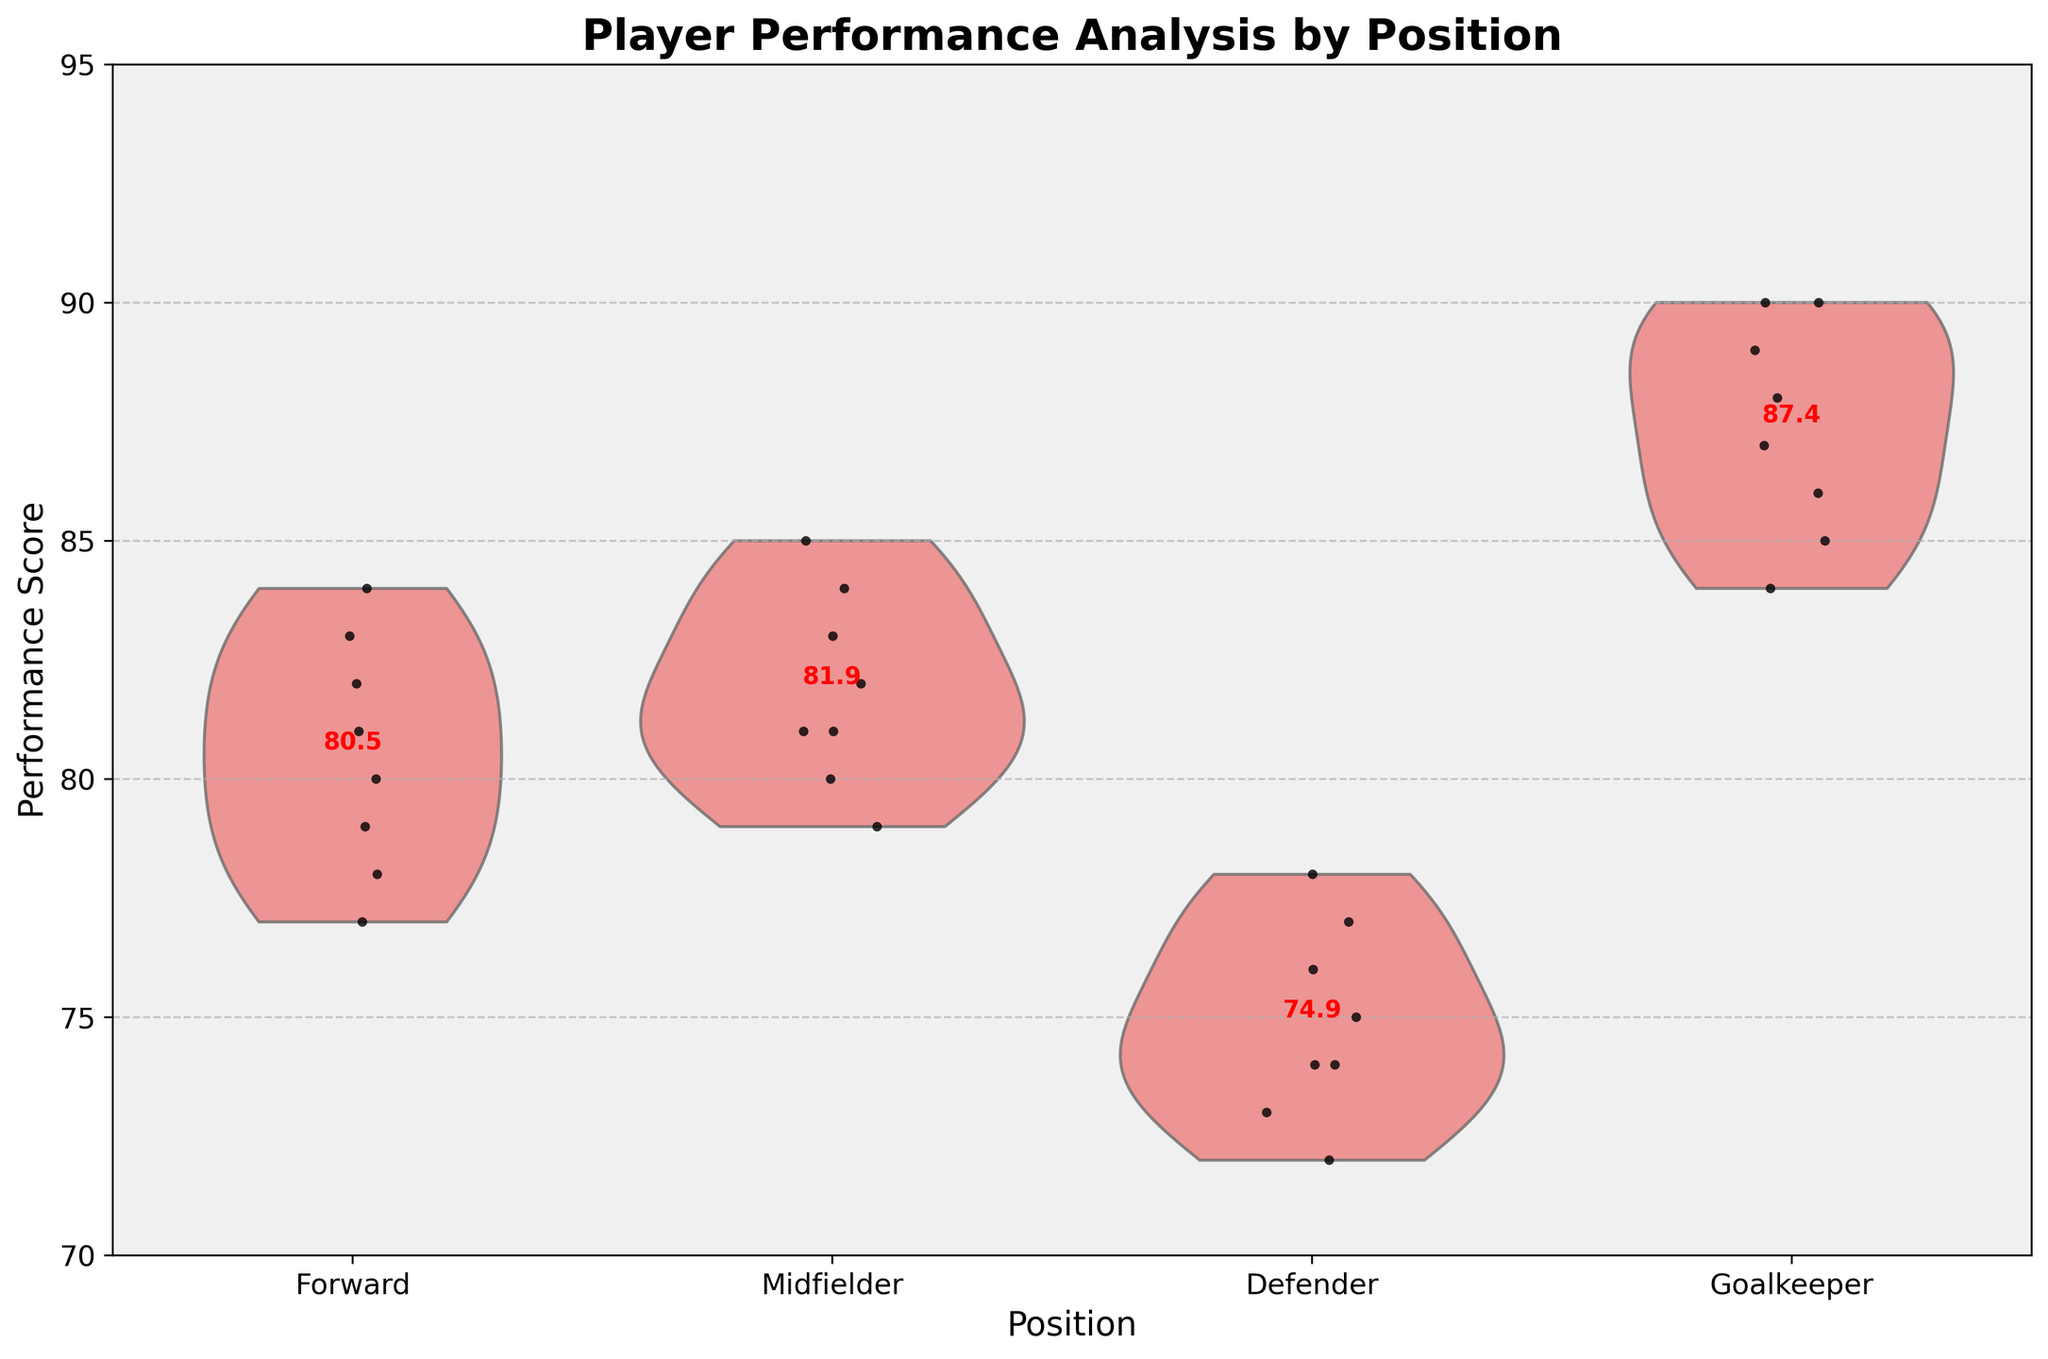What is the title of the chart? The title of the chart is found at the top and it summarizes the main information the chart intends to show. Here, it states "Player Performance Analysis by Position".
Answer: Player Performance Analysis by Position What positions are represented in the chart? The positions can be identified along the x-axis labels, which include Forward, Midfielder, Defender, and Goalkeeper.
Answer: Forward, Midfielder, Defender, Goalkeeper What is the range of performance scores shown in the y-axis? The y-axis provides the scale for the performance scores, ranging from the minimum value at the bottom to the maximum value at the top. In this plot, it ranges from 70 to 95.
Answer: 70 to 95 Which position has the highest mean performance score and what is its value? The mean performance scores are noted with red text at each position. The position with the highest mean value being annotated is the Goalkeeper with a mean score of 87.4.
Answer: Goalkeeper, 87.4 How does the mean performance score of Defenders compare to Forwards? To compare, we look at the mean scores annotated in red for both positions. Forwards have a mean score of 80.0, while Defenders have a mean score of 74.4.
Answer: Forwards: 80.0, Defenders: 74.4 Which position has the largest variability in performance scores? Variability can be observed by the width and spread of the violin plot. The position with the widest spread from top to bottom in its violin plot, indicating larger variability, is the Goalkeeper.
Answer: Goalkeeper Based on the jittered points, which position has the highest individual performance score and what is it? Jittered points, shown as black dots, represent individual scores. The highest point is near the top of the Goalkeeper's violin plot, at around 90.
Answer: Goalkeeper, 90 How does the spread of performance scores for Midfielders compare to Forwards? By examining the width and distribution of the points in the violins, both positions have scores ranging from about 79 to 85, indicating a similar spread. However, Midfielders' data point distribution appears somewhat more centered compared to Forwards.
Answer: Similar spread, slightly more centered for Midfielders Are there any positions where the performance scores do not go below 75? Looking at the bottom limits of the violin plots and jittered points, all positions have some scores below 75, but Defenders have points clearly below 75, while the other positions don't fall below 75 as frequently.
Answer: No, all positions have scores below 75 What percentage of total performance scores belong to Goalkeepers? To calculate this, we would count Goalkeepers' scores and divide by total scores. There are 8 Goalkeepers' scores out of a total of 32 scores (8*4 positions), so (8/32) * 100 = 25%.
Answer: 25% 